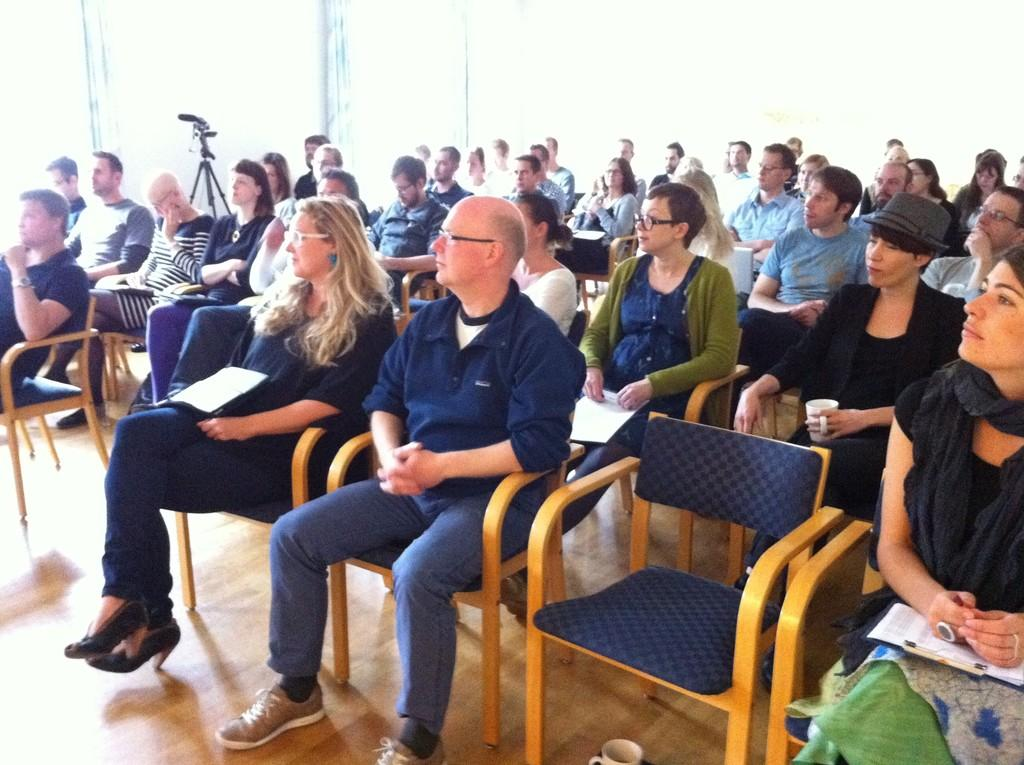What color is the floor in the image? The floor in the image is yellow. What are the people in the image doing? The people in the image are sitting on chairs. What color are the chairs in the image? The chairs in the image are yellow. What type of mine is visible in the image? There is no mine present in the image. Is there a birthday celebration happening in the image? There is no indication of a birthday celebration in the image. 